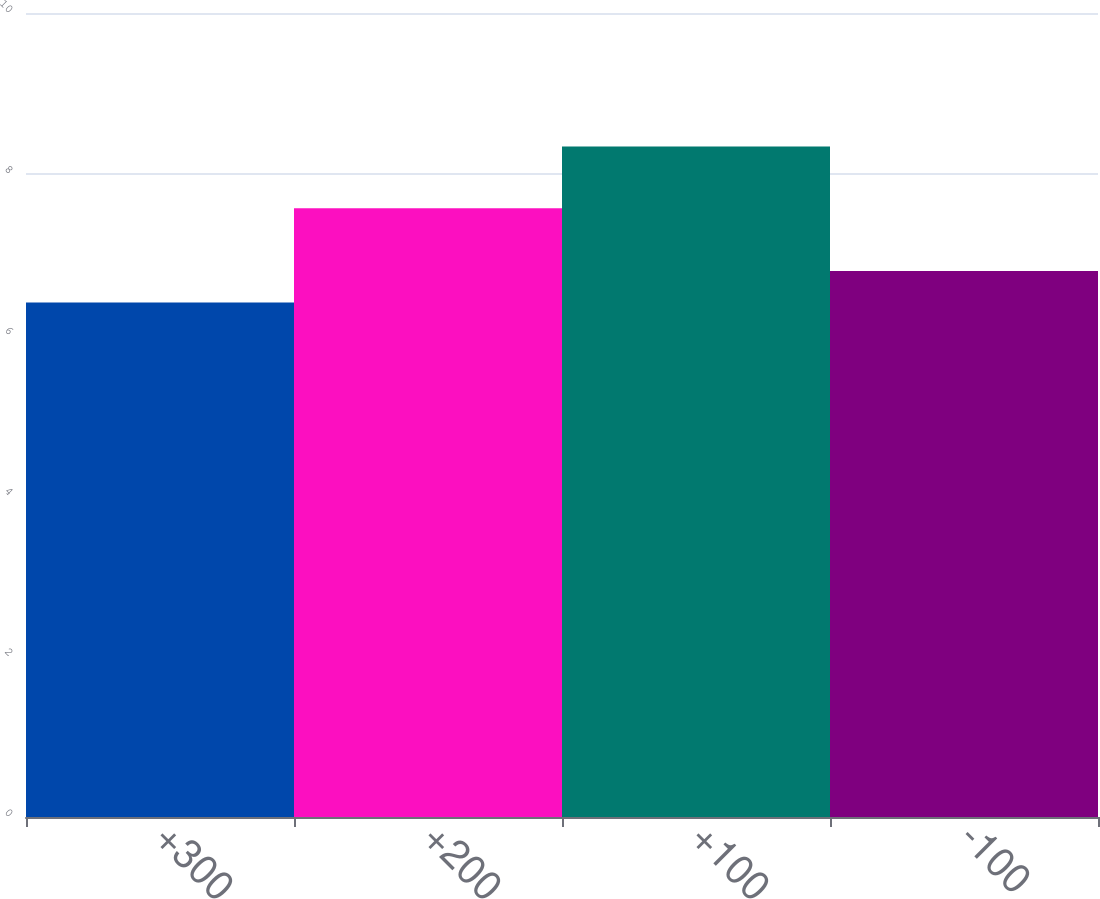Convert chart. <chart><loc_0><loc_0><loc_500><loc_500><bar_chart><fcel>+300<fcel>+200<fcel>+100<fcel>-100<nl><fcel>6.4<fcel>7.57<fcel>8.34<fcel>6.79<nl></chart> 